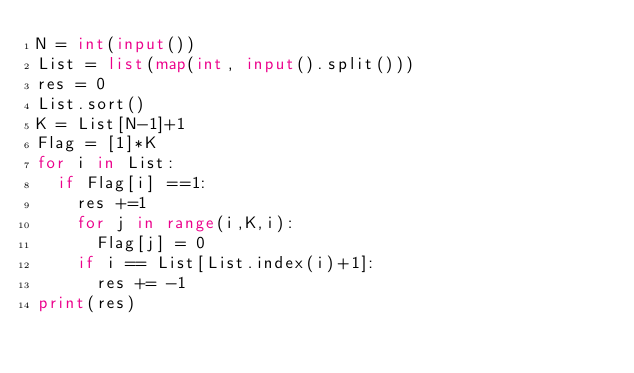Convert code to text. <code><loc_0><loc_0><loc_500><loc_500><_Python_>N = int(input())
List = list(map(int, input().split()))
res = 0
List.sort()
K = List[N-1]+1
Flag = [1]*K
for i in List:
  if Flag[i] ==1:
    res +=1
    for j in range(i,K,i):
      Flag[j] = 0
    if i == List[List.index(i)+1]:
      res += -1
print(res)</code> 